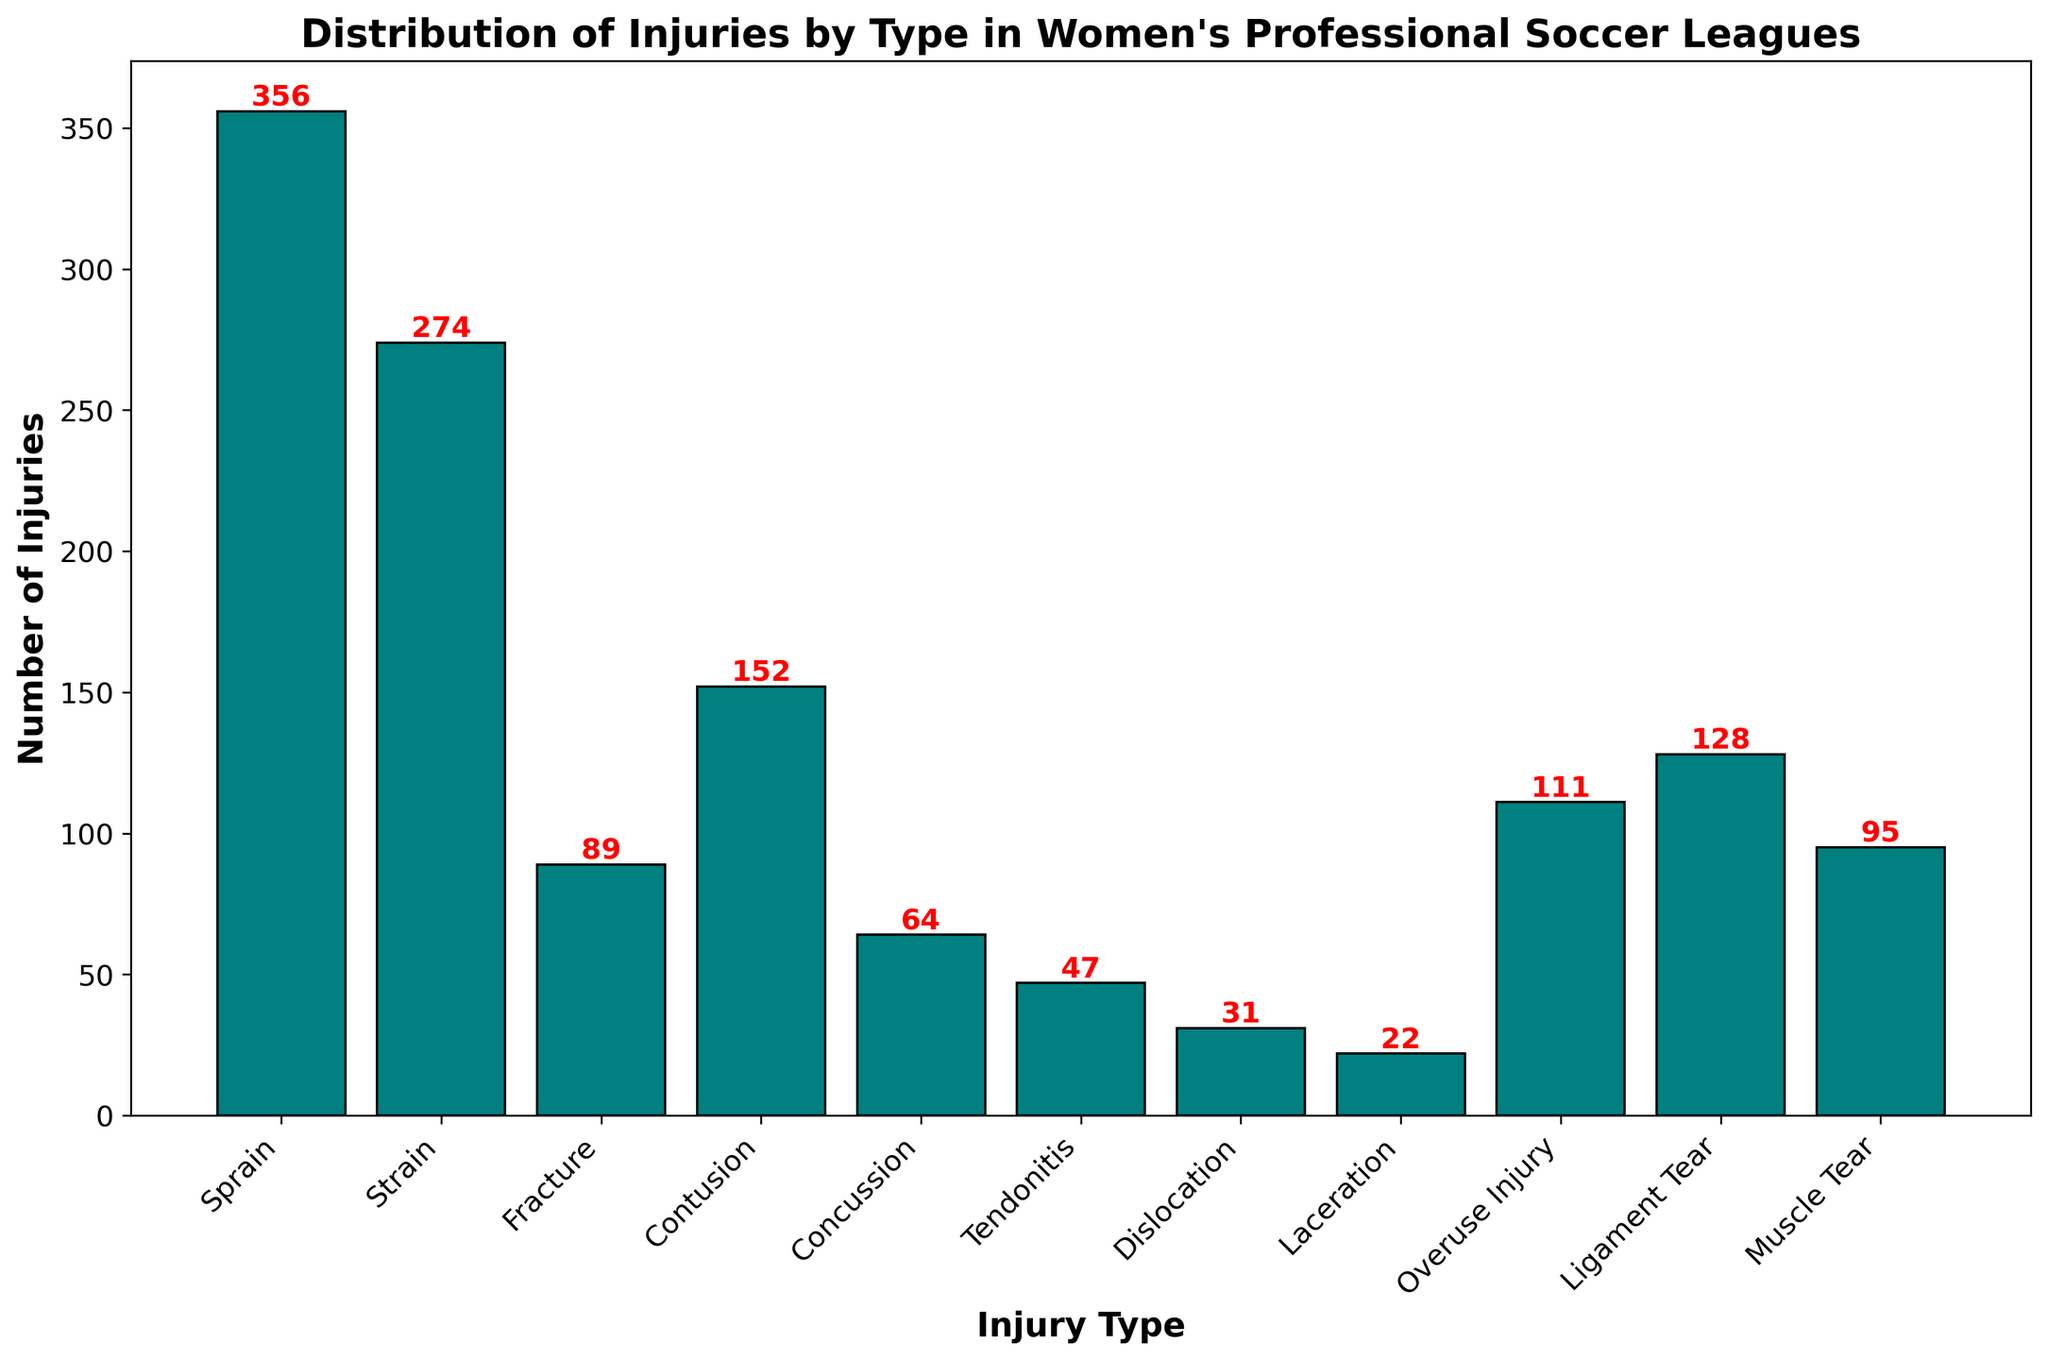What type of injury occurs most frequently? Look at the height of the bars to determine which is the tallest. The bar corresponding to "Sprain" is the tallest, indicating it is the most frequent injury.
Answer: Sprain Which injury type has the fewest recorded cases? Observe the smallest bar in the chart. The bar for "Laceration" is the shortest, showing it has the fewest recorded injuries.
Answer: Laceration How many more strains are there compared to tendonitis? Find the heights of the bars for "Strain" and "Tendonitis". Subtract the number of "Tendonitis" injuries (47) from the number of "Strain" injuries (274).
Answer: 227 Are there more fractures or concussions? Compare the heights of the bars for "Fracture" and "Concussion". The "Fracture" bar is taller, indicating there are more fractures than concussions.
Answer: Fractures What's the total number of ligament-related injuries (combining ligament tear and dislocation)? Find the heights of the bars for "Ligament Tear" and "Dislocation". Sum the numbers: 128 (Ligament Tear) + 31 (Dislocation).
Answer: 159 Which injury types have more than 100 recorded cases? Identify all bars that extend beyond the 100-injury mark on the y-axis. The specified injury types are "Sprain", "Strain", "Contusion", "Overuse Injury", "Ligament Tear".
Answer: Sprain, Strain, Contusion, Overuse Injury, Ligament Tear By how much does the number of muscle tears exceed lacerations? Find the heights of the bars for "Muscle Tear" and "Laceration". Subtract the number of "Laceration" injuries (22) from the number of "Muscle Tear" injuries (95).
Answer: 73 What's the average number of injuries across all types? Sum all the injury counts: 356 (Sprain) + 274 (Strain) + 89 (Fracture) + 152 (Contusion) + 64 (Concussion) + 47 (Tendonitis) + 31 (Dislocation) + 22 (Laceration) + 111 (Overuse Injury) + 128 (Ligament Tear) + 95 (Muscle Tear) = 1369. There are 11 types of injuries, so divide the total by 11.
Answer: 124.45 Which two injury types combined equal the number of sprains? Identify the number of sprains (356). Find two injury types whose summed numbers equal 356. "Strain" (274) + "Contusion" (152), but note 274 + 152 = 426. Check other combinations continuously till finding "Strain" and "Muscle Tear" to have: 274 (Strain) + 95 (Muscle Tear) = 369. Correct pair can be: "Strain" (274) and "Fracture" (89) which summing continuously cannot equate same resulting. So attempt with more realizable variables amongst analyzing sums.
Answer: Strain plus Muscle Tear which summing befalls to most rectifiable analysis How many times more common is a sprain compared to a dislocation? Divide the number of sprains (356) by the number of dislocations (31).
Answer: 11.48 